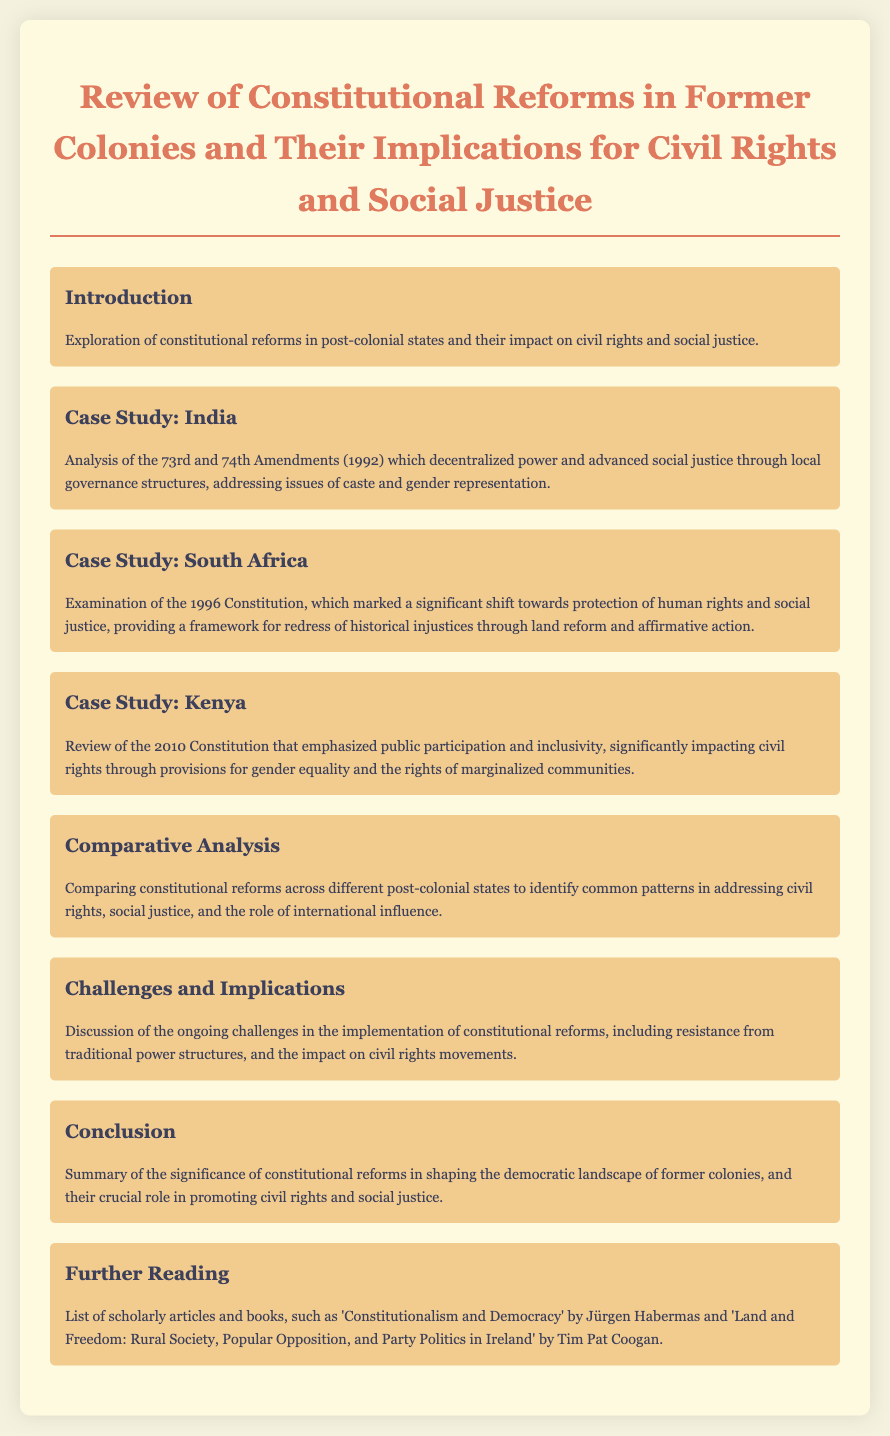What is the title of the document? The title of the document is located in the header section, which provides the main focus of the document.
Answer: Review of Constitutional Reforms in Former Colonies and Their Implications for Civil Rights and Social Justice What significant constitutional amendments occurred in India in 1992? The document highlights specific amendments that decentralized power and focused on social justice.
Answer: 73rd and 74th Amendments When was the South African Constitution adopted? The constitution marked a significant legal change in post-apartheid South Africa and is mentioned in the case study.
Answer: 1996 What is one major theme discussed in the comparative analysis? This section of the document compares reforms across various states, addressing overarching themes.
Answer: Addressing civil rights What year was the Kenyan Constitution enacted? The constitution mentioned focuses on inclusivity and civil rights improvements in Kenya.
Answer: 2010 What is one challenge to the implementation of constitutional reforms? This section addresses ongoing issues that complicate the enforcement of reforms discussed.
Answer: Resistance from traditional power structures What does the conclusion summarize? The conclusion section ties together the document's main arguments regarding the reforms.
Answer: Significance of constitutional reforms Who is one author mentioned in the further reading section? The further reading section suggests scholarly works that provide additional context and depth to the subject.
Answer: Jürgen Habermas 